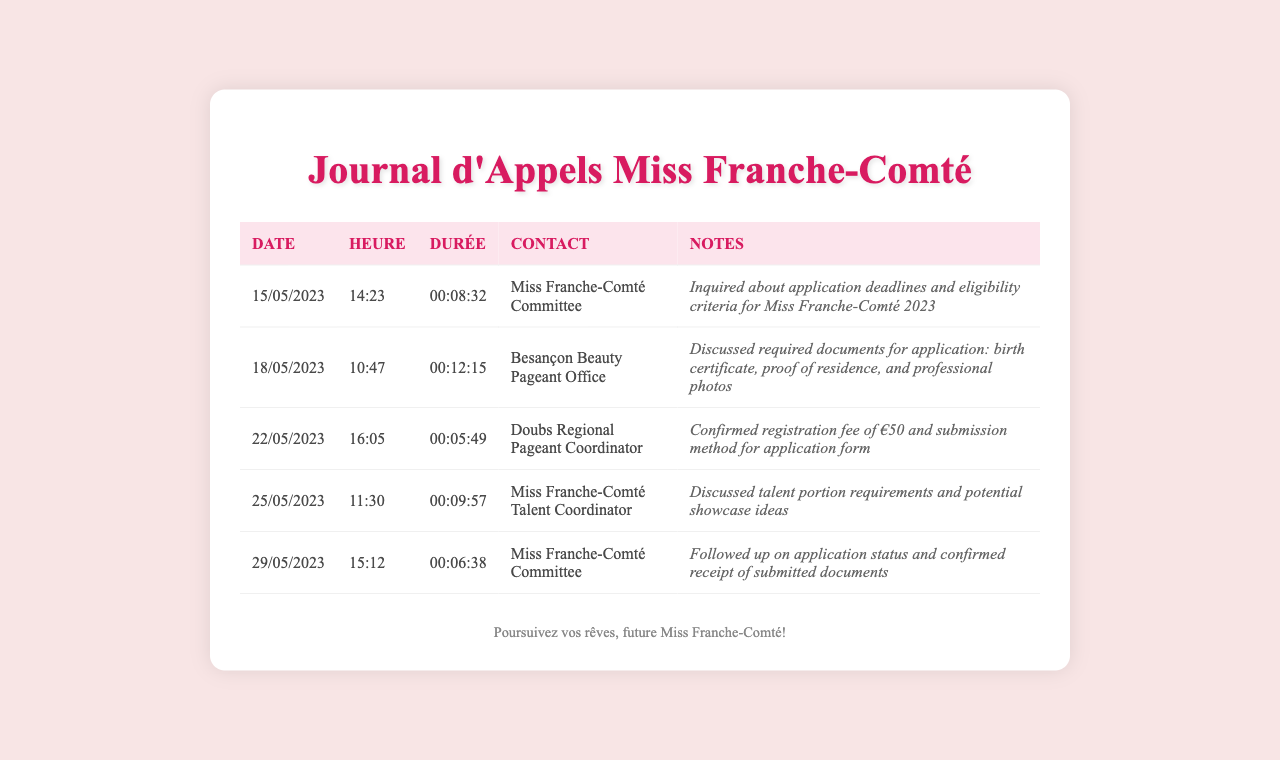what is the date of the first call? The first call in the log is dated 15/05/2023.
Answer: 15/05/2023 who was contacted on 18/05/2023? The contact for the call on 18/05/2023 was the Besançon Beauty Pageant Office.
Answer: Besançon Beauty Pageant Office how long did the call with the Doubs Regional Pageant Coordinator last? The duration of the call with the Doubs Regional Pageant Coordinator was 00:05:49.
Answer: 00:05:49 what was confirmed during the call on 22/05/2023? During the call on 22/05/2023, the registration fee and submission method were confirmed.
Answer: Registration fee of €50 and submission method which topic was discussed during the call with the Talent Coordinator? The topic discussed with the Miss Franche-Comté Talent Coordinator was talent portion requirements.
Answer: Talent portion requirements how many calls were made to the Miss Franche-Comté Committee? There were two calls made to the Miss Franche-Comté Committee in the log.
Answer: Two calls what is the purpose of this document? The purpose of this document is to log calls related to the Miss Franche-Comté application process.
Answer: Call log for Miss Franche-Comté application process 